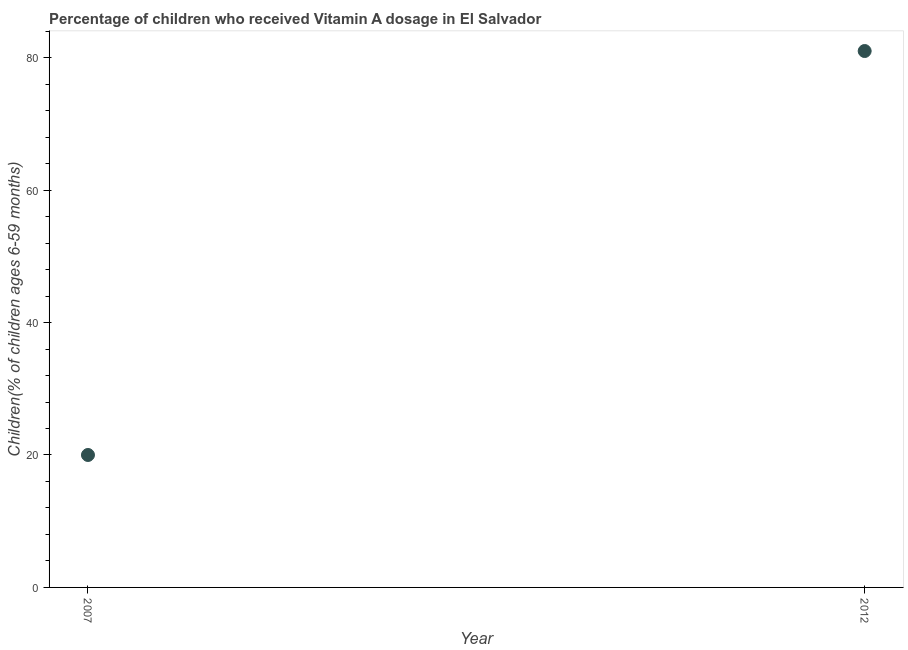What is the vitamin a supplementation coverage rate in 2007?
Your answer should be compact. 20. Across all years, what is the maximum vitamin a supplementation coverage rate?
Your answer should be very brief. 81. Across all years, what is the minimum vitamin a supplementation coverage rate?
Your answer should be very brief. 20. In which year was the vitamin a supplementation coverage rate maximum?
Make the answer very short. 2012. What is the sum of the vitamin a supplementation coverage rate?
Provide a short and direct response. 101. What is the difference between the vitamin a supplementation coverage rate in 2007 and 2012?
Provide a short and direct response. -61. What is the average vitamin a supplementation coverage rate per year?
Your answer should be very brief. 50.5. What is the median vitamin a supplementation coverage rate?
Give a very brief answer. 50.5. What is the ratio of the vitamin a supplementation coverage rate in 2007 to that in 2012?
Keep it short and to the point. 0.25. Is the vitamin a supplementation coverage rate in 2007 less than that in 2012?
Your answer should be compact. Yes. In how many years, is the vitamin a supplementation coverage rate greater than the average vitamin a supplementation coverage rate taken over all years?
Your response must be concise. 1. How many years are there in the graph?
Give a very brief answer. 2. What is the difference between two consecutive major ticks on the Y-axis?
Keep it short and to the point. 20. Are the values on the major ticks of Y-axis written in scientific E-notation?
Offer a very short reply. No. Does the graph contain any zero values?
Offer a terse response. No. What is the title of the graph?
Give a very brief answer. Percentage of children who received Vitamin A dosage in El Salvador. What is the label or title of the Y-axis?
Give a very brief answer. Children(% of children ages 6-59 months). What is the Children(% of children ages 6-59 months) in 2007?
Keep it short and to the point. 20. What is the difference between the Children(% of children ages 6-59 months) in 2007 and 2012?
Your response must be concise. -61. What is the ratio of the Children(% of children ages 6-59 months) in 2007 to that in 2012?
Offer a terse response. 0.25. 